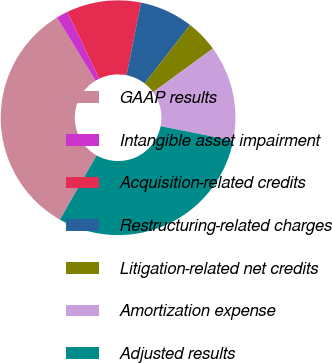<chart> <loc_0><loc_0><loc_500><loc_500><pie_chart><fcel>GAAP results<fcel>Intangible asset impairment<fcel>Acquisition-related credits<fcel>Restructuring-related charges<fcel>Litigation-related net credits<fcel>Amortization expense<fcel>Adjusted results<nl><fcel>33.03%<fcel>1.58%<fcel>10.26%<fcel>7.37%<fcel>4.47%<fcel>13.16%<fcel>30.13%<nl></chart> 